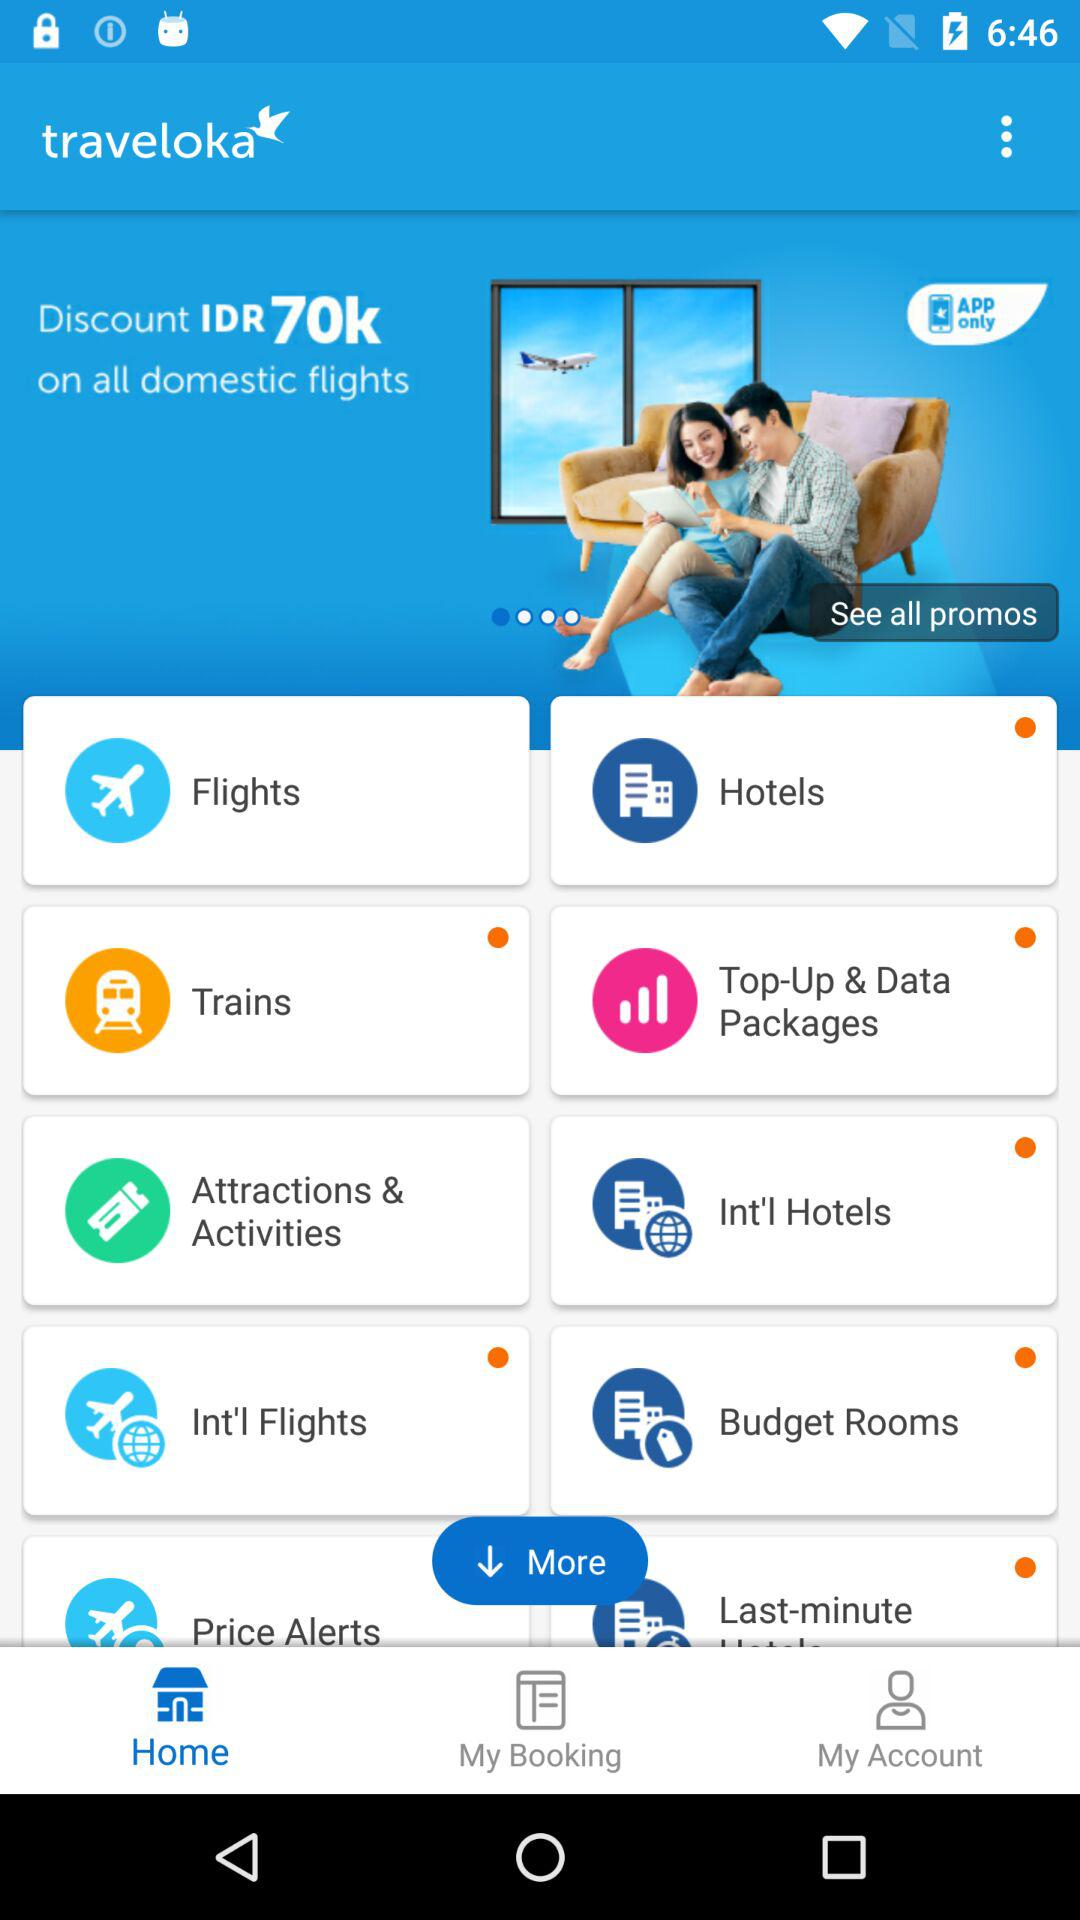What is the discount amount on all domestic flights? The discount amount is IDR70k. 